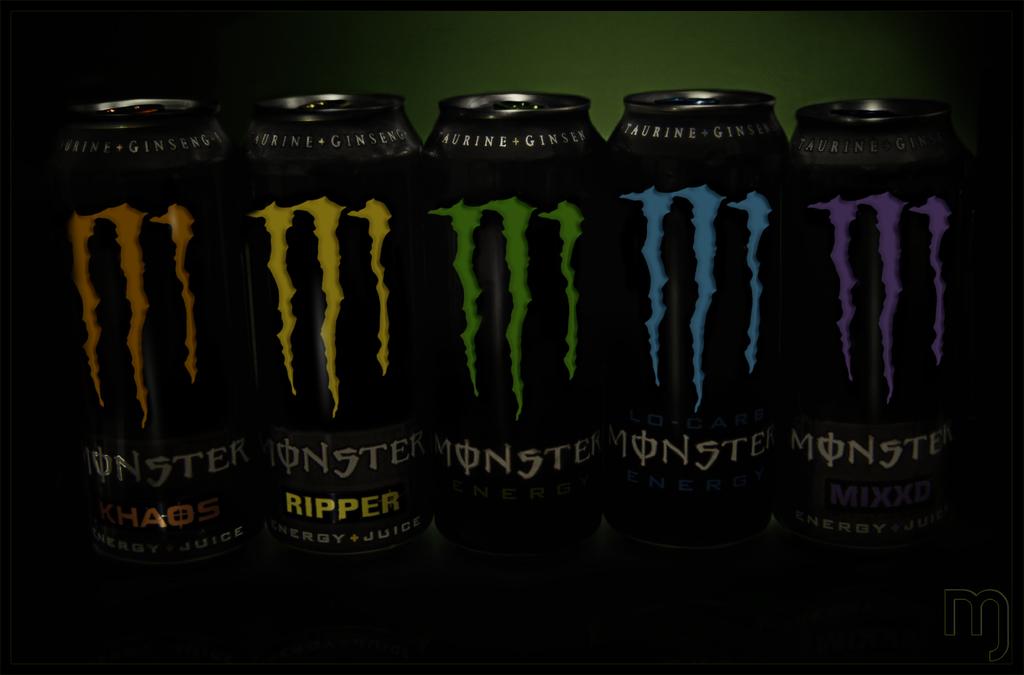What variation is the yellow drink?
Offer a very short reply. Ripper. What brand are these drinks?
Provide a succinct answer. Monster. 